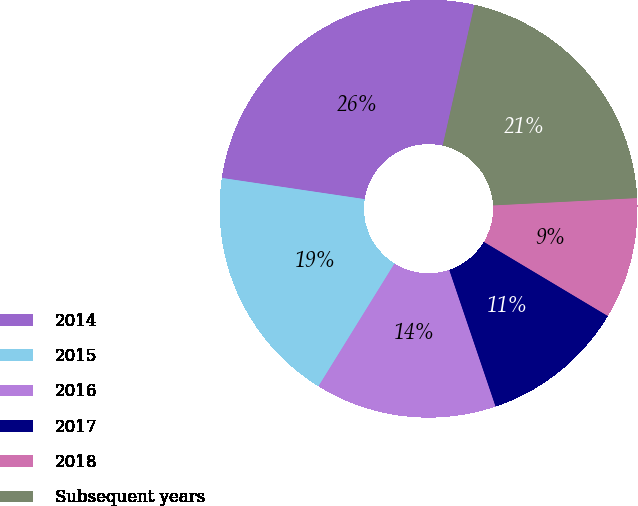Convert chart. <chart><loc_0><loc_0><loc_500><loc_500><pie_chart><fcel>2014<fcel>2015<fcel>2016<fcel>2017<fcel>2018<fcel>Subsequent years<nl><fcel>26.19%<fcel>18.52%<fcel>14.03%<fcel>11.22%<fcel>9.39%<fcel>20.66%<nl></chart> 